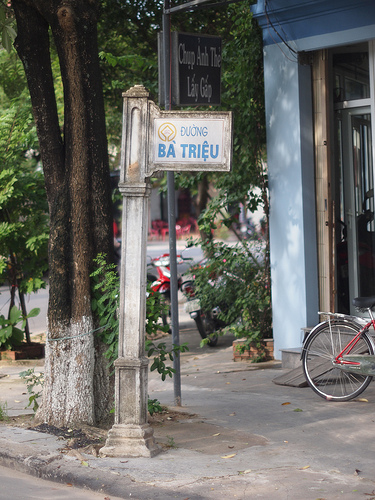Imagine a magical event happening in this scene. What would it be? Imagine at twilight, the signpost suddenly emanates a soft golden glow, and the street transforms into a whimsical marketplace. Out of nowhere, vendors appear with magical goods—enchanted fruits, sparkling garments, and potions that promise unimaginable adventures. Trees whisper stories of old, and the bicycle transforms into a flying contraption. People from across different realms gather, sharing their tales of magic and mystery. The air is filled with a melodic hum, enticing everyone to dance and celebrate under the glowing sky, making this street a nexus of enchantment and wonder. 